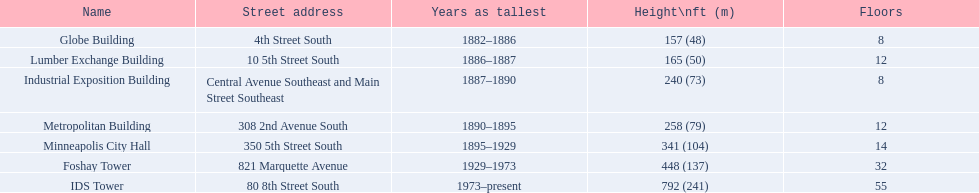How many levels are there in the lumber exchange building? 12. What other structure consists of 12 floors? Metropolitan Building. 